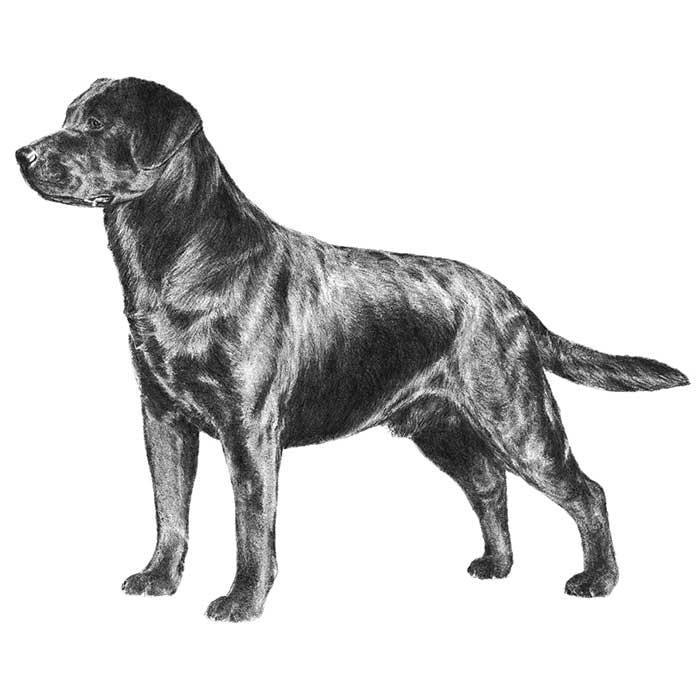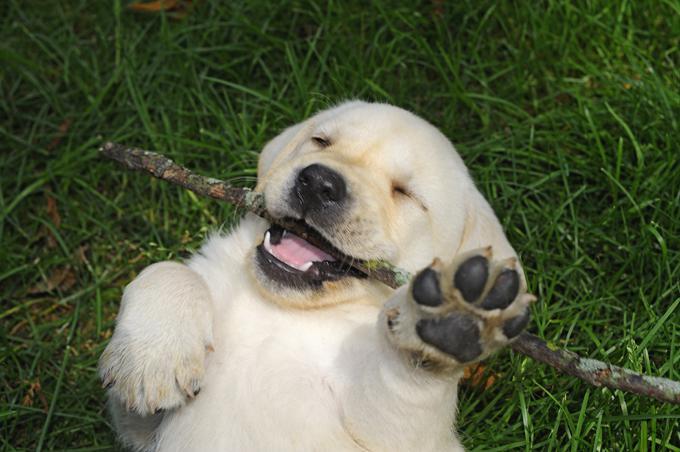The first image is the image on the left, the second image is the image on the right. Evaluate the accuracy of this statement regarding the images: "There are two dogs in the image on the right.". Is it true? Answer yes or no. No. 